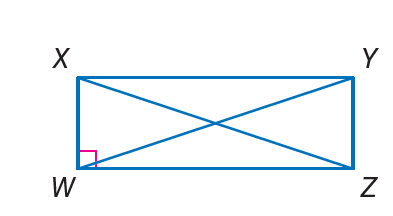Answer the mathemtical geometry problem and directly provide the correct option letter.
Question: Quadrilateral W X Y Z is a rectangle. If X W = 3, W Z = 4, and X Z = b, find Y W.
Choices: A: 3 B: 4 C: 5 D: 6 C 